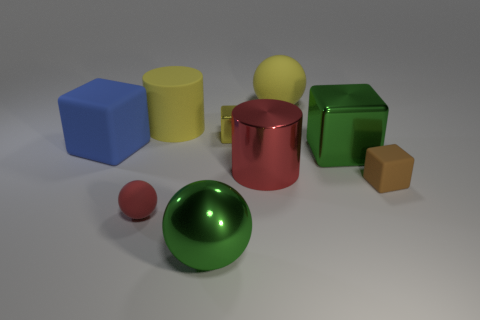Subtract 1 blocks. How many blocks are left? 3 Add 1 large red shiny things. How many objects exist? 10 Subtract all balls. How many objects are left? 6 Add 2 green things. How many green things exist? 4 Subtract 0 gray spheres. How many objects are left? 9 Subtract all small cyan shiny objects. Subtract all large cubes. How many objects are left? 7 Add 7 big balls. How many big balls are left? 9 